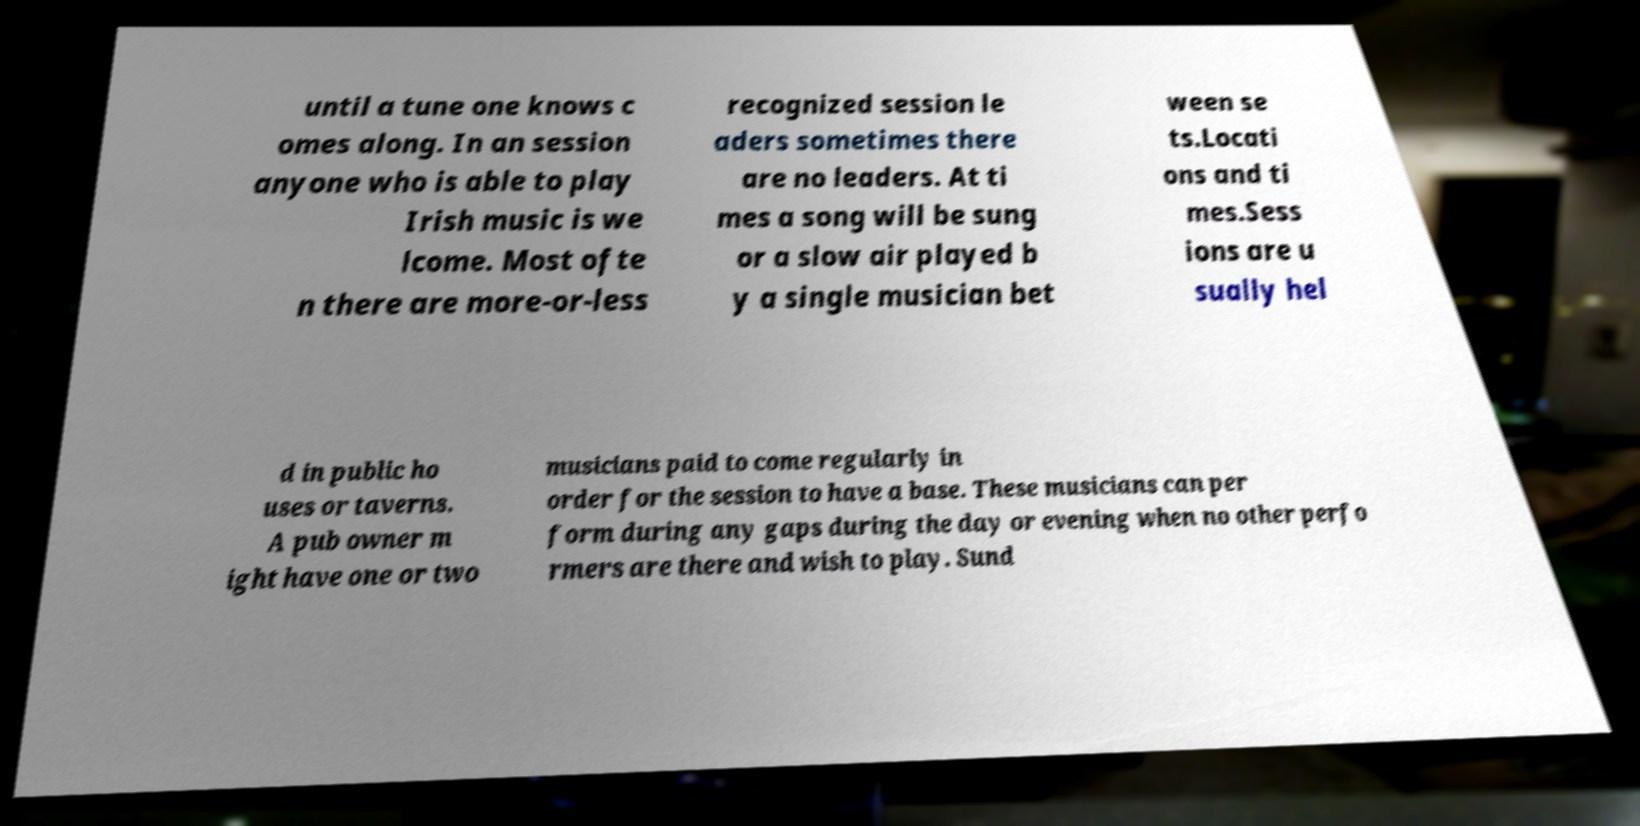Can you read and provide the text displayed in the image?This photo seems to have some interesting text. Can you extract and type it out for me? until a tune one knows c omes along. In an session anyone who is able to play Irish music is we lcome. Most ofte n there are more-or-less recognized session le aders sometimes there are no leaders. At ti mes a song will be sung or a slow air played b y a single musician bet ween se ts.Locati ons and ti mes.Sess ions are u sually hel d in public ho uses or taverns. A pub owner m ight have one or two musicians paid to come regularly in order for the session to have a base. These musicians can per form during any gaps during the day or evening when no other perfo rmers are there and wish to play. Sund 